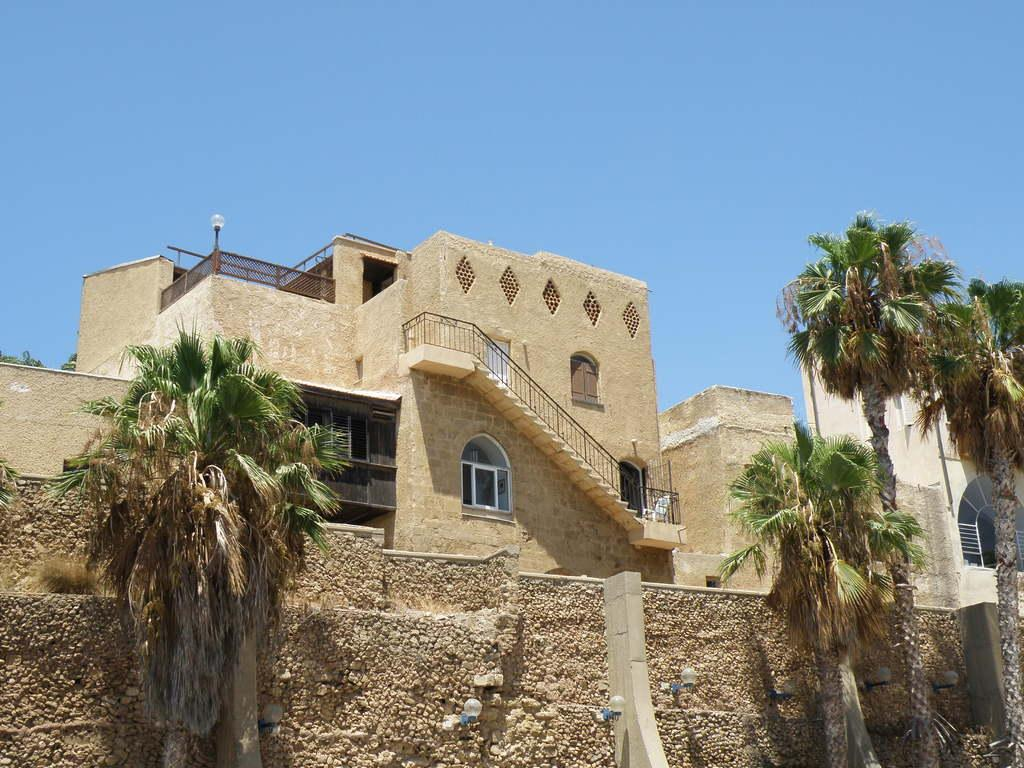What type of structures are present in the image? There are buildings in the image. What can be seen in front of the buildings? There are trees in front of the buildings. What part of the natural environment is visible in the image? The sky is visible in the background of the image. What type of crime is being committed in the image? There is no indication of any crime being committed in the image; it features buildings, trees, and the sky. How old is the daughter in the image? There is no daughter present in the image. 